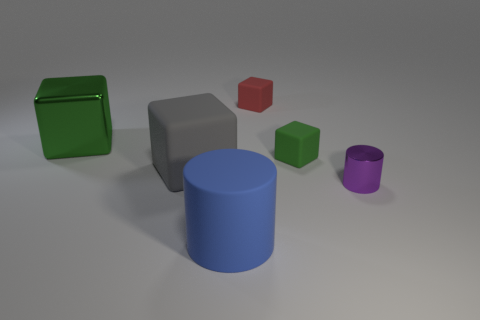Add 2 big red matte objects. How many objects exist? 8 Subtract all matte blocks. How many blocks are left? 1 Subtract 1 cylinders. How many cylinders are left? 1 Subtract all blue cylinders. How many cylinders are left? 1 Subtract all purple cylinders. Subtract all red balls. How many cylinders are left? 1 Subtract all blue spheres. How many purple cylinders are left? 1 Subtract all large yellow rubber cylinders. Subtract all small green cubes. How many objects are left? 5 Add 3 big green things. How many big green things are left? 4 Add 4 purple metal objects. How many purple metal objects exist? 5 Subtract 1 blue cylinders. How many objects are left? 5 